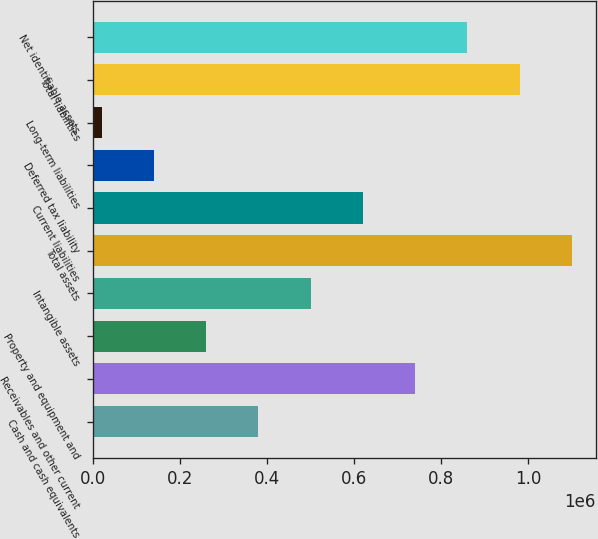Convert chart to OTSL. <chart><loc_0><loc_0><loc_500><loc_500><bar_chart><fcel>Cash and cash equivalents<fcel>Receivables and other current<fcel>Property and equipment and<fcel>Intangible assets<fcel>Total assets<fcel>Current liabilities<fcel>Deferred tax liability<fcel>Long-term liabilities<fcel>Total liabilities<fcel>Net identifiable assets<nl><fcel>380193<fcel>739971<fcel>260268<fcel>500119<fcel>1.09975e+06<fcel>620045<fcel>140342<fcel>20416<fcel>979822<fcel>859897<nl></chart> 